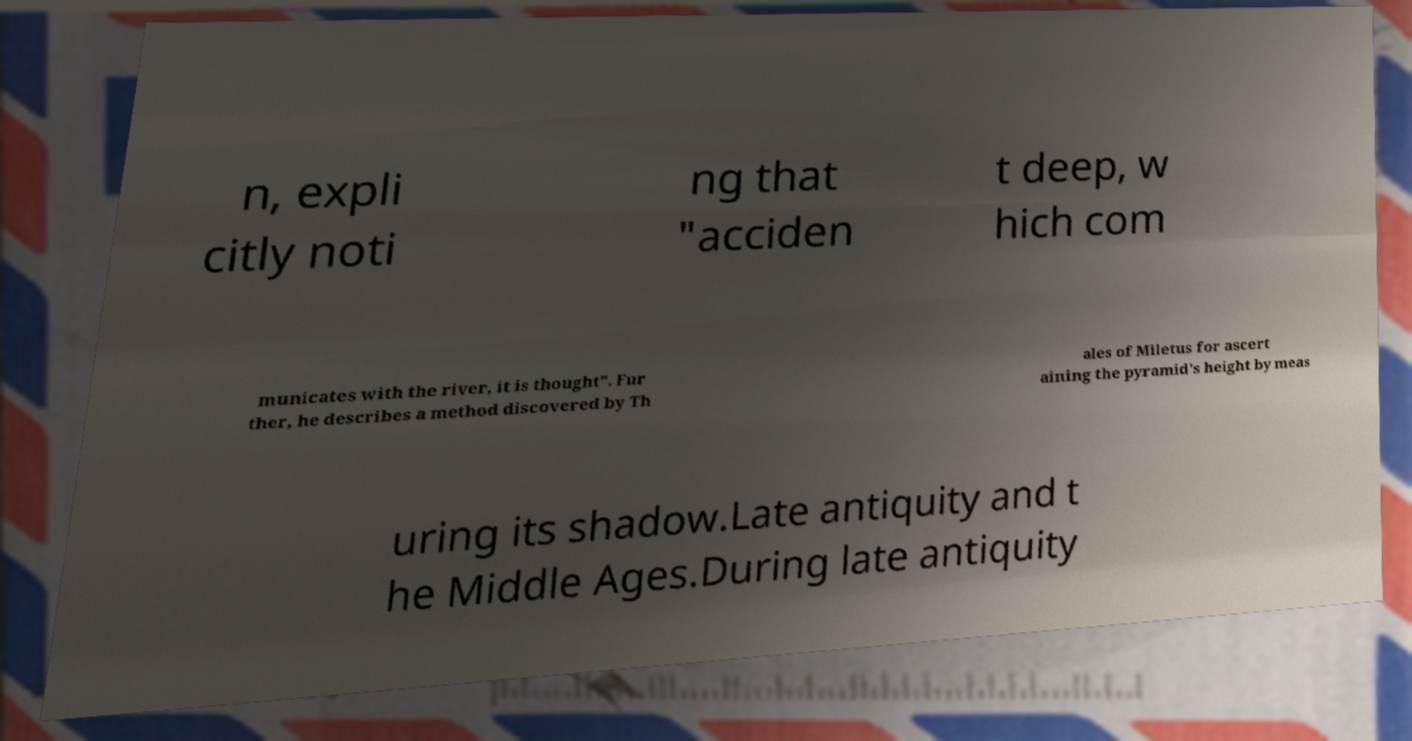Could you extract and type out the text from this image? n, expli citly noti ng that "acciden t deep, w hich com municates with the river, it is thought". Fur ther, he describes a method discovered by Th ales of Miletus for ascert aining the pyramid's height by meas uring its shadow.Late antiquity and t he Middle Ages.During late antiquity 